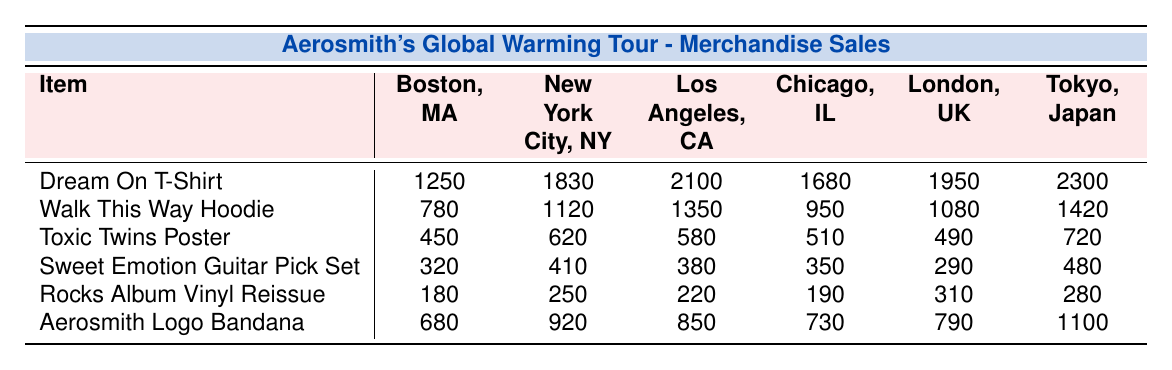What item sold the most in Tokyo, Japan? According to the table, the item that sold the most in Tokyo is the "Dream On T-Shirt," with sales of 2300 units.
Answer: Dream On T-Shirt Which location had the lowest sales for the "Toxic Twins Poster"? The lowest sales for the "Toxic Twins Poster" occurred in Boston, MA, with 450 units sold.
Answer: Boston, MA What is the total sales for the "Aerosmith Logo Bandana" across all locations? To find the total sales for the "Aerosmith Logo Bandana," sum the sales from each location: 680 + 920 + 850 + 730 + 790 + 1100 = 4070.
Answer: 4070 What is the average sales of the "Walk This Way Hoodie" across all locations? To calculate the average sales, sum the sales: 780 + 1120 + 1350 + 950 + 1080 + 1420 = 5300, then divide by the number of locations (6): 5300 / 6 = 883.33.
Answer: 883.33 Did more than 2000 units of the "Sweet Emotion Guitar Pick Set" sell in any location? In the table, we see that the highest sales for the "Sweet Emotion Guitar Pick Set" is 480 in Tokyo, which is less than 2000 units. Thus, the answer is no.
Answer: No Which item had the highest sales in Los Angeles, CA, and what was that number? The table shows that the "Dream On T-Shirt" had the highest sales in Los Angeles, CA, totaling 2100 units.
Answer: Dream On T-Shirt, 2100 What is the difference in sales for the "Rocks Album Vinyl Reissue" between London, UK, and Chicago, IL? The sales in London for the "Rocks Album Vinyl Reissue" is 310, while in Chicago, it is 190. The difference is: 310 - 190 = 120.
Answer: 120 In which city did the "Toxic Twins Poster" sell more than 500 units? By reviewing the sales data, we see that the following cities had sales exceeding 500 for the "Toxic Twins Poster": New York City (620), Los Angeles (580), Chicago (510), and Tokyo (720).
Answer: New York City, Los Angeles, Chicago, Tokyo 